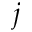<formula> <loc_0><loc_0><loc_500><loc_500>j</formula> 